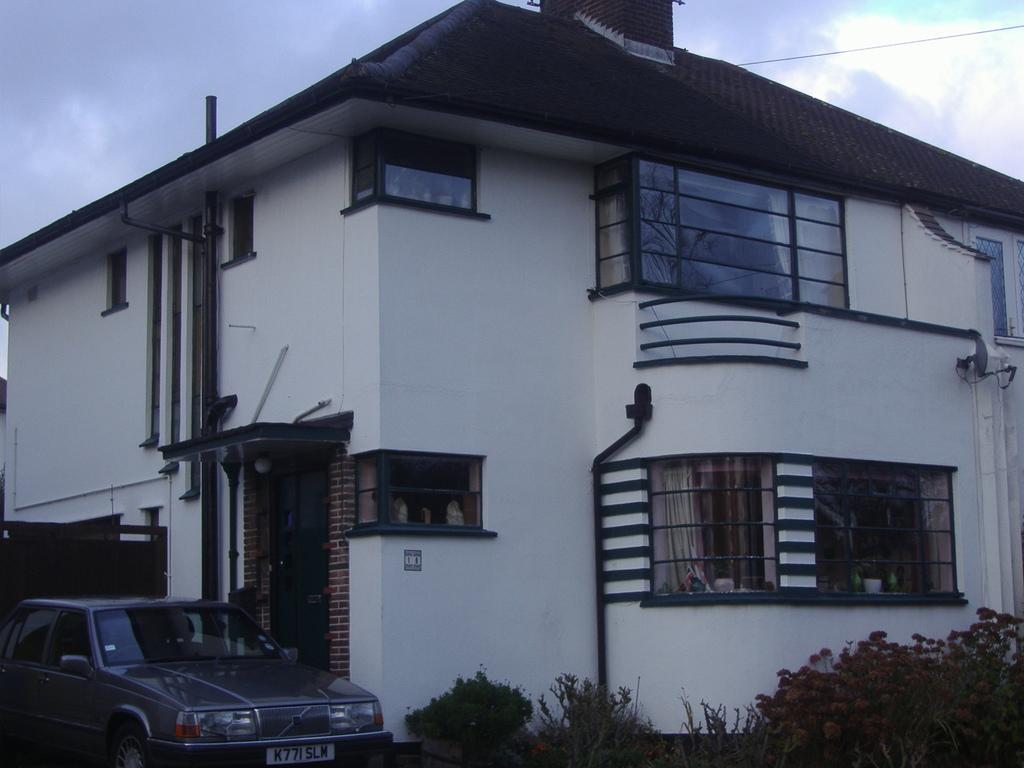How would you summarize this image in a sentence or two? In this picture we can see a car, plants, building, some objects and in the background we can see the sky. 